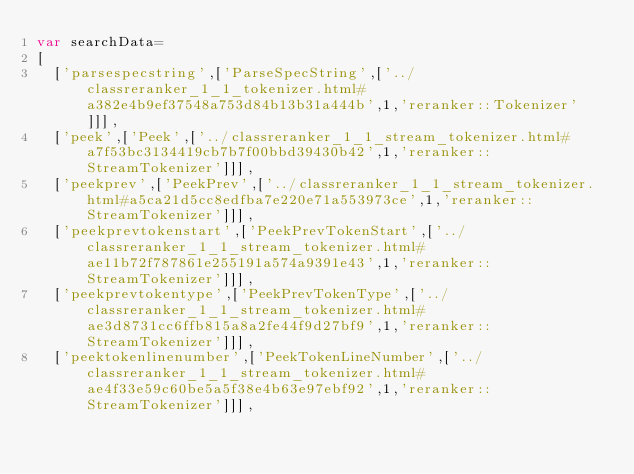<code> <loc_0><loc_0><loc_500><loc_500><_JavaScript_>var searchData=
[
  ['parsespecstring',['ParseSpecString',['../classreranker_1_1_tokenizer.html#a382e4b9ef37548a753d84b13b31a444b',1,'reranker::Tokenizer']]],
  ['peek',['Peek',['../classreranker_1_1_stream_tokenizer.html#a7f53bc3134419cb7b7f00bbd39430b42',1,'reranker::StreamTokenizer']]],
  ['peekprev',['PeekPrev',['../classreranker_1_1_stream_tokenizer.html#a5ca21d5cc8edfba7e220e71a553973ce',1,'reranker::StreamTokenizer']]],
  ['peekprevtokenstart',['PeekPrevTokenStart',['../classreranker_1_1_stream_tokenizer.html#ae11b72f787861e255191a574a9391e43',1,'reranker::StreamTokenizer']]],
  ['peekprevtokentype',['PeekPrevTokenType',['../classreranker_1_1_stream_tokenizer.html#ae3d8731cc6ffb815a8a2fe44f9d27bf9',1,'reranker::StreamTokenizer']]],
  ['peektokenlinenumber',['PeekTokenLineNumber',['../classreranker_1_1_stream_tokenizer.html#ae4f33e59c60be5a5f38e4b63e97ebf92',1,'reranker::StreamTokenizer']]],</code> 